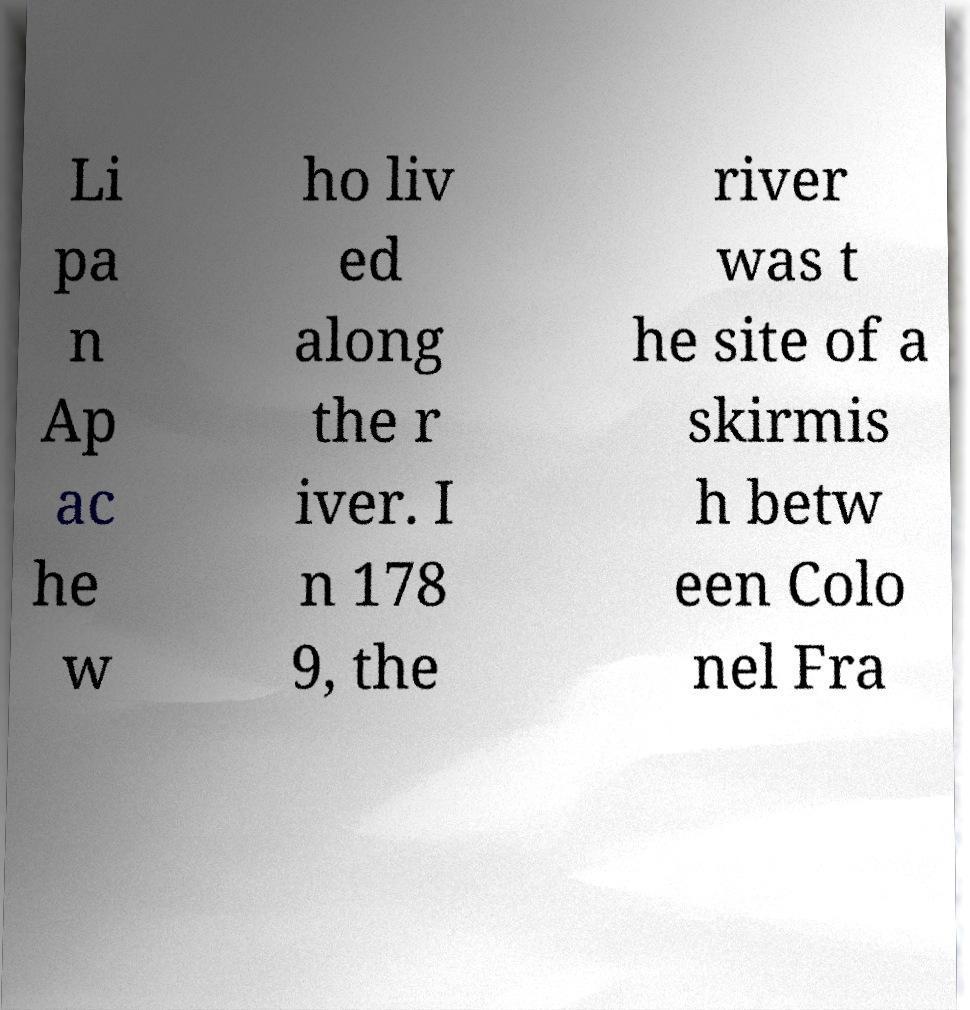Can you read and provide the text displayed in the image?This photo seems to have some interesting text. Can you extract and type it out for me? Li pa n Ap ac he w ho liv ed along the r iver. I n 178 9, the river was t he site of a skirmis h betw een Colo nel Fra 